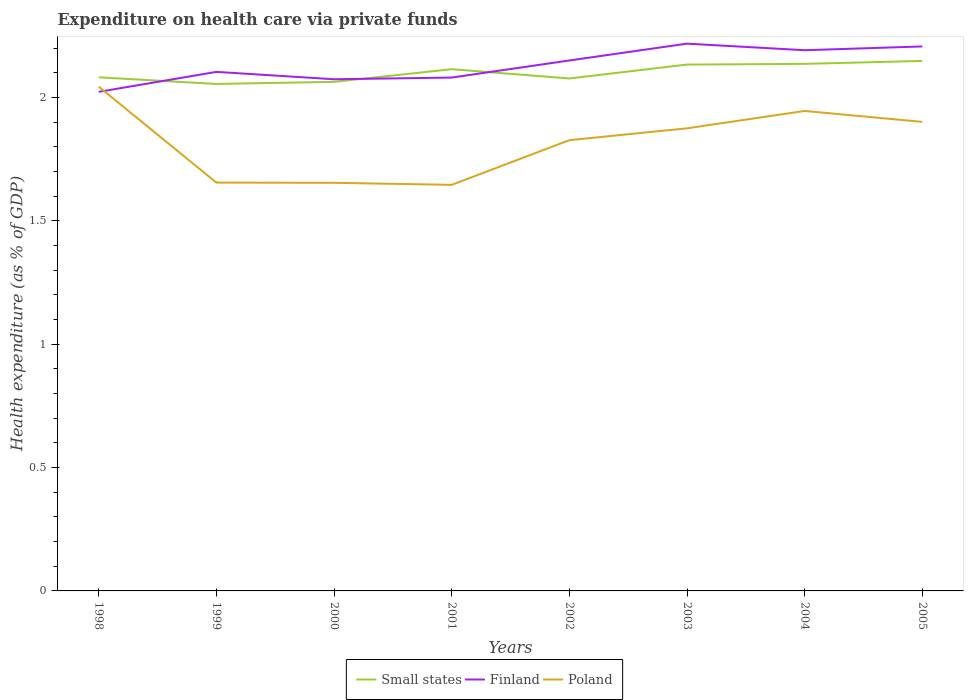Does the line corresponding to Poland intersect with the line corresponding to Small states?
Ensure brevity in your answer.  No. Across all years, what is the maximum expenditure made on health care in Poland?
Your response must be concise. 1.65. In which year was the expenditure made on health care in Poland maximum?
Your answer should be very brief. 2001. What is the total expenditure made on health care in Finland in the graph?
Ensure brevity in your answer.  -0.14. What is the difference between the highest and the second highest expenditure made on health care in Small states?
Provide a short and direct response. 0.09. What is the difference between the highest and the lowest expenditure made on health care in Poland?
Provide a succinct answer. 5. Is the expenditure made on health care in Poland strictly greater than the expenditure made on health care in Small states over the years?
Make the answer very short. Yes. How many years are there in the graph?
Your answer should be compact. 8. Does the graph contain any zero values?
Make the answer very short. No. Where does the legend appear in the graph?
Provide a short and direct response. Bottom center. How are the legend labels stacked?
Ensure brevity in your answer.  Horizontal. What is the title of the graph?
Keep it short and to the point. Expenditure on health care via private funds. What is the label or title of the Y-axis?
Your answer should be very brief. Health expenditure (as % of GDP). What is the Health expenditure (as % of GDP) of Small states in 1998?
Your answer should be compact. 2.08. What is the Health expenditure (as % of GDP) in Finland in 1998?
Provide a short and direct response. 2.02. What is the Health expenditure (as % of GDP) of Poland in 1998?
Your answer should be very brief. 2.04. What is the Health expenditure (as % of GDP) of Small states in 1999?
Your answer should be compact. 2.06. What is the Health expenditure (as % of GDP) in Finland in 1999?
Your response must be concise. 2.1. What is the Health expenditure (as % of GDP) of Poland in 1999?
Offer a terse response. 1.66. What is the Health expenditure (as % of GDP) of Small states in 2000?
Keep it short and to the point. 2.06. What is the Health expenditure (as % of GDP) in Finland in 2000?
Give a very brief answer. 2.07. What is the Health expenditure (as % of GDP) in Poland in 2000?
Make the answer very short. 1.65. What is the Health expenditure (as % of GDP) in Small states in 2001?
Offer a very short reply. 2.12. What is the Health expenditure (as % of GDP) of Finland in 2001?
Make the answer very short. 2.08. What is the Health expenditure (as % of GDP) of Poland in 2001?
Ensure brevity in your answer.  1.65. What is the Health expenditure (as % of GDP) of Small states in 2002?
Your answer should be compact. 2.08. What is the Health expenditure (as % of GDP) in Finland in 2002?
Your answer should be very brief. 2.15. What is the Health expenditure (as % of GDP) in Poland in 2002?
Give a very brief answer. 1.83. What is the Health expenditure (as % of GDP) in Small states in 2003?
Offer a very short reply. 2.13. What is the Health expenditure (as % of GDP) of Finland in 2003?
Provide a short and direct response. 2.22. What is the Health expenditure (as % of GDP) of Poland in 2003?
Provide a succinct answer. 1.88. What is the Health expenditure (as % of GDP) in Small states in 2004?
Provide a short and direct response. 2.14. What is the Health expenditure (as % of GDP) of Finland in 2004?
Ensure brevity in your answer.  2.19. What is the Health expenditure (as % of GDP) of Poland in 2004?
Offer a very short reply. 1.95. What is the Health expenditure (as % of GDP) of Small states in 2005?
Offer a very short reply. 2.15. What is the Health expenditure (as % of GDP) of Finland in 2005?
Make the answer very short. 2.21. What is the Health expenditure (as % of GDP) in Poland in 2005?
Your answer should be very brief. 1.9. Across all years, what is the maximum Health expenditure (as % of GDP) of Small states?
Provide a short and direct response. 2.15. Across all years, what is the maximum Health expenditure (as % of GDP) of Finland?
Your response must be concise. 2.22. Across all years, what is the maximum Health expenditure (as % of GDP) of Poland?
Provide a succinct answer. 2.04. Across all years, what is the minimum Health expenditure (as % of GDP) of Small states?
Provide a succinct answer. 2.06. Across all years, what is the minimum Health expenditure (as % of GDP) in Finland?
Your answer should be compact. 2.02. Across all years, what is the minimum Health expenditure (as % of GDP) of Poland?
Offer a terse response. 1.65. What is the total Health expenditure (as % of GDP) of Small states in the graph?
Offer a terse response. 16.82. What is the total Health expenditure (as % of GDP) of Finland in the graph?
Your answer should be very brief. 17.05. What is the total Health expenditure (as % of GDP) in Poland in the graph?
Your response must be concise. 14.55. What is the difference between the Health expenditure (as % of GDP) in Small states in 1998 and that in 1999?
Give a very brief answer. 0.03. What is the difference between the Health expenditure (as % of GDP) of Finland in 1998 and that in 1999?
Give a very brief answer. -0.08. What is the difference between the Health expenditure (as % of GDP) of Poland in 1998 and that in 1999?
Ensure brevity in your answer.  0.39. What is the difference between the Health expenditure (as % of GDP) of Small states in 1998 and that in 2000?
Give a very brief answer. 0.02. What is the difference between the Health expenditure (as % of GDP) in Finland in 1998 and that in 2000?
Provide a succinct answer. -0.05. What is the difference between the Health expenditure (as % of GDP) in Poland in 1998 and that in 2000?
Your answer should be very brief. 0.39. What is the difference between the Health expenditure (as % of GDP) of Small states in 1998 and that in 2001?
Provide a succinct answer. -0.03. What is the difference between the Health expenditure (as % of GDP) in Finland in 1998 and that in 2001?
Ensure brevity in your answer.  -0.06. What is the difference between the Health expenditure (as % of GDP) in Poland in 1998 and that in 2001?
Offer a terse response. 0.4. What is the difference between the Health expenditure (as % of GDP) of Small states in 1998 and that in 2002?
Offer a very short reply. 0. What is the difference between the Health expenditure (as % of GDP) of Finland in 1998 and that in 2002?
Keep it short and to the point. -0.13. What is the difference between the Health expenditure (as % of GDP) of Poland in 1998 and that in 2002?
Provide a short and direct response. 0.22. What is the difference between the Health expenditure (as % of GDP) in Small states in 1998 and that in 2003?
Give a very brief answer. -0.05. What is the difference between the Health expenditure (as % of GDP) in Finland in 1998 and that in 2003?
Offer a terse response. -0.2. What is the difference between the Health expenditure (as % of GDP) of Poland in 1998 and that in 2003?
Offer a very short reply. 0.17. What is the difference between the Health expenditure (as % of GDP) of Small states in 1998 and that in 2004?
Keep it short and to the point. -0.05. What is the difference between the Health expenditure (as % of GDP) in Finland in 1998 and that in 2004?
Your answer should be compact. -0.17. What is the difference between the Health expenditure (as % of GDP) in Poland in 1998 and that in 2004?
Make the answer very short. 0.1. What is the difference between the Health expenditure (as % of GDP) of Small states in 1998 and that in 2005?
Your response must be concise. -0.07. What is the difference between the Health expenditure (as % of GDP) of Finland in 1998 and that in 2005?
Provide a short and direct response. -0.18. What is the difference between the Health expenditure (as % of GDP) in Poland in 1998 and that in 2005?
Your answer should be compact. 0.14. What is the difference between the Health expenditure (as % of GDP) of Small states in 1999 and that in 2000?
Offer a terse response. -0.01. What is the difference between the Health expenditure (as % of GDP) in Finland in 1999 and that in 2000?
Offer a terse response. 0.03. What is the difference between the Health expenditure (as % of GDP) in Poland in 1999 and that in 2000?
Your response must be concise. 0. What is the difference between the Health expenditure (as % of GDP) in Small states in 1999 and that in 2001?
Provide a succinct answer. -0.06. What is the difference between the Health expenditure (as % of GDP) of Finland in 1999 and that in 2001?
Your answer should be very brief. 0.02. What is the difference between the Health expenditure (as % of GDP) in Poland in 1999 and that in 2001?
Offer a terse response. 0.01. What is the difference between the Health expenditure (as % of GDP) of Small states in 1999 and that in 2002?
Your answer should be very brief. -0.02. What is the difference between the Health expenditure (as % of GDP) of Finland in 1999 and that in 2002?
Offer a very short reply. -0.05. What is the difference between the Health expenditure (as % of GDP) in Poland in 1999 and that in 2002?
Your answer should be compact. -0.17. What is the difference between the Health expenditure (as % of GDP) of Small states in 1999 and that in 2003?
Make the answer very short. -0.08. What is the difference between the Health expenditure (as % of GDP) in Finland in 1999 and that in 2003?
Make the answer very short. -0.11. What is the difference between the Health expenditure (as % of GDP) of Poland in 1999 and that in 2003?
Offer a terse response. -0.22. What is the difference between the Health expenditure (as % of GDP) in Small states in 1999 and that in 2004?
Make the answer very short. -0.08. What is the difference between the Health expenditure (as % of GDP) in Finland in 1999 and that in 2004?
Ensure brevity in your answer.  -0.09. What is the difference between the Health expenditure (as % of GDP) of Poland in 1999 and that in 2004?
Offer a terse response. -0.29. What is the difference between the Health expenditure (as % of GDP) of Small states in 1999 and that in 2005?
Keep it short and to the point. -0.09. What is the difference between the Health expenditure (as % of GDP) of Finland in 1999 and that in 2005?
Your answer should be compact. -0.1. What is the difference between the Health expenditure (as % of GDP) in Poland in 1999 and that in 2005?
Ensure brevity in your answer.  -0.25. What is the difference between the Health expenditure (as % of GDP) in Small states in 2000 and that in 2001?
Offer a very short reply. -0.05. What is the difference between the Health expenditure (as % of GDP) of Finland in 2000 and that in 2001?
Keep it short and to the point. -0.01. What is the difference between the Health expenditure (as % of GDP) in Poland in 2000 and that in 2001?
Give a very brief answer. 0.01. What is the difference between the Health expenditure (as % of GDP) of Small states in 2000 and that in 2002?
Offer a very short reply. -0.01. What is the difference between the Health expenditure (as % of GDP) of Finland in 2000 and that in 2002?
Offer a terse response. -0.08. What is the difference between the Health expenditure (as % of GDP) in Poland in 2000 and that in 2002?
Provide a succinct answer. -0.17. What is the difference between the Health expenditure (as % of GDP) of Small states in 2000 and that in 2003?
Offer a very short reply. -0.07. What is the difference between the Health expenditure (as % of GDP) in Finland in 2000 and that in 2003?
Ensure brevity in your answer.  -0.14. What is the difference between the Health expenditure (as % of GDP) in Poland in 2000 and that in 2003?
Ensure brevity in your answer.  -0.22. What is the difference between the Health expenditure (as % of GDP) of Small states in 2000 and that in 2004?
Make the answer very short. -0.07. What is the difference between the Health expenditure (as % of GDP) in Finland in 2000 and that in 2004?
Ensure brevity in your answer.  -0.12. What is the difference between the Health expenditure (as % of GDP) in Poland in 2000 and that in 2004?
Ensure brevity in your answer.  -0.29. What is the difference between the Health expenditure (as % of GDP) in Small states in 2000 and that in 2005?
Offer a terse response. -0.08. What is the difference between the Health expenditure (as % of GDP) in Finland in 2000 and that in 2005?
Make the answer very short. -0.13. What is the difference between the Health expenditure (as % of GDP) in Poland in 2000 and that in 2005?
Provide a short and direct response. -0.25. What is the difference between the Health expenditure (as % of GDP) in Small states in 2001 and that in 2002?
Offer a very short reply. 0.04. What is the difference between the Health expenditure (as % of GDP) in Finland in 2001 and that in 2002?
Your response must be concise. -0.07. What is the difference between the Health expenditure (as % of GDP) of Poland in 2001 and that in 2002?
Offer a terse response. -0.18. What is the difference between the Health expenditure (as % of GDP) in Small states in 2001 and that in 2003?
Offer a terse response. -0.02. What is the difference between the Health expenditure (as % of GDP) in Finland in 2001 and that in 2003?
Offer a terse response. -0.14. What is the difference between the Health expenditure (as % of GDP) in Poland in 2001 and that in 2003?
Provide a succinct answer. -0.23. What is the difference between the Health expenditure (as % of GDP) in Small states in 2001 and that in 2004?
Make the answer very short. -0.02. What is the difference between the Health expenditure (as % of GDP) of Finland in 2001 and that in 2004?
Provide a short and direct response. -0.11. What is the difference between the Health expenditure (as % of GDP) in Poland in 2001 and that in 2004?
Provide a short and direct response. -0.3. What is the difference between the Health expenditure (as % of GDP) in Small states in 2001 and that in 2005?
Offer a terse response. -0.03. What is the difference between the Health expenditure (as % of GDP) in Finland in 2001 and that in 2005?
Your response must be concise. -0.13. What is the difference between the Health expenditure (as % of GDP) in Poland in 2001 and that in 2005?
Your answer should be very brief. -0.26. What is the difference between the Health expenditure (as % of GDP) in Small states in 2002 and that in 2003?
Offer a terse response. -0.06. What is the difference between the Health expenditure (as % of GDP) in Finland in 2002 and that in 2003?
Keep it short and to the point. -0.07. What is the difference between the Health expenditure (as % of GDP) of Poland in 2002 and that in 2003?
Provide a succinct answer. -0.05. What is the difference between the Health expenditure (as % of GDP) of Small states in 2002 and that in 2004?
Provide a short and direct response. -0.06. What is the difference between the Health expenditure (as % of GDP) in Finland in 2002 and that in 2004?
Your response must be concise. -0.04. What is the difference between the Health expenditure (as % of GDP) in Poland in 2002 and that in 2004?
Your answer should be very brief. -0.12. What is the difference between the Health expenditure (as % of GDP) in Small states in 2002 and that in 2005?
Keep it short and to the point. -0.07. What is the difference between the Health expenditure (as % of GDP) in Finland in 2002 and that in 2005?
Offer a very short reply. -0.06. What is the difference between the Health expenditure (as % of GDP) in Poland in 2002 and that in 2005?
Make the answer very short. -0.07. What is the difference between the Health expenditure (as % of GDP) in Small states in 2003 and that in 2004?
Make the answer very short. -0. What is the difference between the Health expenditure (as % of GDP) in Finland in 2003 and that in 2004?
Ensure brevity in your answer.  0.03. What is the difference between the Health expenditure (as % of GDP) in Poland in 2003 and that in 2004?
Make the answer very short. -0.07. What is the difference between the Health expenditure (as % of GDP) of Small states in 2003 and that in 2005?
Give a very brief answer. -0.01. What is the difference between the Health expenditure (as % of GDP) in Finland in 2003 and that in 2005?
Ensure brevity in your answer.  0.01. What is the difference between the Health expenditure (as % of GDP) in Poland in 2003 and that in 2005?
Your response must be concise. -0.03. What is the difference between the Health expenditure (as % of GDP) of Small states in 2004 and that in 2005?
Offer a terse response. -0.01. What is the difference between the Health expenditure (as % of GDP) in Finland in 2004 and that in 2005?
Your response must be concise. -0.02. What is the difference between the Health expenditure (as % of GDP) in Poland in 2004 and that in 2005?
Ensure brevity in your answer.  0.04. What is the difference between the Health expenditure (as % of GDP) in Small states in 1998 and the Health expenditure (as % of GDP) in Finland in 1999?
Ensure brevity in your answer.  -0.02. What is the difference between the Health expenditure (as % of GDP) of Small states in 1998 and the Health expenditure (as % of GDP) of Poland in 1999?
Provide a succinct answer. 0.43. What is the difference between the Health expenditure (as % of GDP) in Finland in 1998 and the Health expenditure (as % of GDP) in Poland in 1999?
Offer a very short reply. 0.37. What is the difference between the Health expenditure (as % of GDP) of Small states in 1998 and the Health expenditure (as % of GDP) of Finland in 2000?
Your response must be concise. 0.01. What is the difference between the Health expenditure (as % of GDP) in Small states in 1998 and the Health expenditure (as % of GDP) in Poland in 2000?
Offer a very short reply. 0.43. What is the difference between the Health expenditure (as % of GDP) of Finland in 1998 and the Health expenditure (as % of GDP) of Poland in 2000?
Offer a terse response. 0.37. What is the difference between the Health expenditure (as % of GDP) of Small states in 1998 and the Health expenditure (as % of GDP) of Finland in 2001?
Ensure brevity in your answer.  0. What is the difference between the Health expenditure (as % of GDP) of Small states in 1998 and the Health expenditure (as % of GDP) of Poland in 2001?
Your answer should be compact. 0.44. What is the difference between the Health expenditure (as % of GDP) of Finland in 1998 and the Health expenditure (as % of GDP) of Poland in 2001?
Offer a very short reply. 0.38. What is the difference between the Health expenditure (as % of GDP) of Small states in 1998 and the Health expenditure (as % of GDP) of Finland in 2002?
Give a very brief answer. -0.07. What is the difference between the Health expenditure (as % of GDP) of Small states in 1998 and the Health expenditure (as % of GDP) of Poland in 2002?
Your response must be concise. 0.26. What is the difference between the Health expenditure (as % of GDP) in Finland in 1998 and the Health expenditure (as % of GDP) in Poland in 2002?
Your answer should be very brief. 0.2. What is the difference between the Health expenditure (as % of GDP) in Small states in 1998 and the Health expenditure (as % of GDP) in Finland in 2003?
Provide a short and direct response. -0.14. What is the difference between the Health expenditure (as % of GDP) of Small states in 1998 and the Health expenditure (as % of GDP) of Poland in 2003?
Offer a terse response. 0.21. What is the difference between the Health expenditure (as % of GDP) in Finland in 1998 and the Health expenditure (as % of GDP) in Poland in 2003?
Provide a short and direct response. 0.15. What is the difference between the Health expenditure (as % of GDP) in Small states in 1998 and the Health expenditure (as % of GDP) in Finland in 2004?
Offer a terse response. -0.11. What is the difference between the Health expenditure (as % of GDP) in Small states in 1998 and the Health expenditure (as % of GDP) in Poland in 2004?
Give a very brief answer. 0.14. What is the difference between the Health expenditure (as % of GDP) in Finland in 1998 and the Health expenditure (as % of GDP) in Poland in 2004?
Provide a succinct answer. 0.08. What is the difference between the Health expenditure (as % of GDP) in Small states in 1998 and the Health expenditure (as % of GDP) in Finland in 2005?
Keep it short and to the point. -0.13. What is the difference between the Health expenditure (as % of GDP) of Small states in 1998 and the Health expenditure (as % of GDP) of Poland in 2005?
Your answer should be very brief. 0.18. What is the difference between the Health expenditure (as % of GDP) of Finland in 1998 and the Health expenditure (as % of GDP) of Poland in 2005?
Provide a succinct answer. 0.12. What is the difference between the Health expenditure (as % of GDP) of Small states in 1999 and the Health expenditure (as % of GDP) of Finland in 2000?
Provide a succinct answer. -0.02. What is the difference between the Health expenditure (as % of GDP) of Small states in 1999 and the Health expenditure (as % of GDP) of Poland in 2000?
Offer a very short reply. 0.4. What is the difference between the Health expenditure (as % of GDP) in Finland in 1999 and the Health expenditure (as % of GDP) in Poland in 2000?
Your response must be concise. 0.45. What is the difference between the Health expenditure (as % of GDP) of Small states in 1999 and the Health expenditure (as % of GDP) of Finland in 2001?
Your answer should be compact. -0.03. What is the difference between the Health expenditure (as % of GDP) in Small states in 1999 and the Health expenditure (as % of GDP) in Poland in 2001?
Your answer should be compact. 0.41. What is the difference between the Health expenditure (as % of GDP) in Finland in 1999 and the Health expenditure (as % of GDP) in Poland in 2001?
Keep it short and to the point. 0.46. What is the difference between the Health expenditure (as % of GDP) in Small states in 1999 and the Health expenditure (as % of GDP) in Finland in 2002?
Provide a short and direct response. -0.1. What is the difference between the Health expenditure (as % of GDP) of Small states in 1999 and the Health expenditure (as % of GDP) of Poland in 2002?
Your response must be concise. 0.23. What is the difference between the Health expenditure (as % of GDP) in Finland in 1999 and the Health expenditure (as % of GDP) in Poland in 2002?
Offer a very short reply. 0.28. What is the difference between the Health expenditure (as % of GDP) of Small states in 1999 and the Health expenditure (as % of GDP) of Finland in 2003?
Keep it short and to the point. -0.16. What is the difference between the Health expenditure (as % of GDP) of Small states in 1999 and the Health expenditure (as % of GDP) of Poland in 2003?
Your response must be concise. 0.18. What is the difference between the Health expenditure (as % of GDP) of Finland in 1999 and the Health expenditure (as % of GDP) of Poland in 2003?
Keep it short and to the point. 0.23. What is the difference between the Health expenditure (as % of GDP) of Small states in 1999 and the Health expenditure (as % of GDP) of Finland in 2004?
Ensure brevity in your answer.  -0.14. What is the difference between the Health expenditure (as % of GDP) of Small states in 1999 and the Health expenditure (as % of GDP) of Poland in 2004?
Offer a terse response. 0.11. What is the difference between the Health expenditure (as % of GDP) in Finland in 1999 and the Health expenditure (as % of GDP) in Poland in 2004?
Your answer should be compact. 0.16. What is the difference between the Health expenditure (as % of GDP) in Small states in 1999 and the Health expenditure (as % of GDP) in Finland in 2005?
Keep it short and to the point. -0.15. What is the difference between the Health expenditure (as % of GDP) of Small states in 1999 and the Health expenditure (as % of GDP) of Poland in 2005?
Your answer should be very brief. 0.15. What is the difference between the Health expenditure (as % of GDP) in Finland in 1999 and the Health expenditure (as % of GDP) in Poland in 2005?
Your answer should be compact. 0.2. What is the difference between the Health expenditure (as % of GDP) of Small states in 2000 and the Health expenditure (as % of GDP) of Finland in 2001?
Provide a succinct answer. -0.02. What is the difference between the Health expenditure (as % of GDP) in Small states in 2000 and the Health expenditure (as % of GDP) in Poland in 2001?
Offer a terse response. 0.42. What is the difference between the Health expenditure (as % of GDP) of Finland in 2000 and the Health expenditure (as % of GDP) of Poland in 2001?
Your response must be concise. 0.43. What is the difference between the Health expenditure (as % of GDP) of Small states in 2000 and the Health expenditure (as % of GDP) of Finland in 2002?
Make the answer very short. -0.09. What is the difference between the Health expenditure (as % of GDP) in Small states in 2000 and the Health expenditure (as % of GDP) in Poland in 2002?
Keep it short and to the point. 0.24. What is the difference between the Health expenditure (as % of GDP) of Finland in 2000 and the Health expenditure (as % of GDP) of Poland in 2002?
Provide a succinct answer. 0.25. What is the difference between the Health expenditure (as % of GDP) in Small states in 2000 and the Health expenditure (as % of GDP) in Finland in 2003?
Offer a terse response. -0.15. What is the difference between the Health expenditure (as % of GDP) in Small states in 2000 and the Health expenditure (as % of GDP) in Poland in 2003?
Your answer should be compact. 0.19. What is the difference between the Health expenditure (as % of GDP) in Finland in 2000 and the Health expenditure (as % of GDP) in Poland in 2003?
Ensure brevity in your answer.  0.2. What is the difference between the Health expenditure (as % of GDP) of Small states in 2000 and the Health expenditure (as % of GDP) of Finland in 2004?
Provide a succinct answer. -0.13. What is the difference between the Health expenditure (as % of GDP) in Small states in 2000 and the Health expenditure (as % of GDP) in Poland in 2004?
Offer a very short reply. 0.12. What is the difference between the Health expenditure (as % of GDP) of Finland in 2000 and the Health expenditure (as % of GDP) of Poland in 2004?
Your response must be concise. 0.13. What is the difference between the Health expenditure (as % of GDP) of Small states in 2000 and the Health expenditure (as % of GDP) of Finland in 2005?
Provide a succinct answer. -0.14. What is the difference between the Health expenditure (as % of GDP) of Small states in 2000 and the Health expenditure (as % of GDP) of Poland in 2005?
Provide a short and direct response. 0.16. What is the difference between the Health expenditure (as % of GDP) in Finland in 2000 and the Health expenditure (as % of GDP) in Poland in 2005?
Your answer should be very brief. 0.17. What is the difference between the Health expenditure (as % of GDP) of Small states in 2001 and the Health expenditure (as % of GDP) of Finland in 2002?
Give a very brief answer. -0.04. What is the difference between the Health expenditure (as % of GDP) in Small states in 2001 and the Health expenditure (as % of GDP) in Poland in 2002?
Offer a terse response. 0.29. What is the difference between the Health expenditure (as % of GDP) in Finland in 2001 and the Health expenditure (as % of GDP) in Poland in 2002?
Provide a short and direct response. 0.25. What is the difference between the Health expenditure (as % of GDP) in Small states in 2001 and the Health expenditure (as % of GDP) in Finland in 2003?
Offer a terse response. -0.1. What is the difference between the Health expenditure (as % of GDP) in Small states in 2001 and the Health expenditure (as % of GDP) in Poland in 2003?
Offer a terse response. 0.24. What is the difference between the Health expenditure (as % of GDP) in Finland in 2001 and the Health expenditure (as % of GDP) in Poland in 2003?
Ensure brevity in your answer.  0.21. What is the difference between the Health expenditure (as % of GDP) of Small states in 2001 and the Health expenditure (as % of GDP) of Finland in 2004?
Ensure brevity in your answer.  -0.08. What is the difference between the Health expenditure (as % of GDP) in Small states in 2001 and the Health expenditure (as % of GDP) in Poland in 2004?
Give a very brief answer. 0.17. What is the difference between the Health expenditure (as % of GDP) of Finland in 2001 and the Health expenditure (as % of GDP) of Poland in 2004?
Make the answer very short. 0.14. What is the difference between the Health expenditure (as % of GDP) of Small states in 2001 and the Health expenditure (as % of GDP) of Finland in 2005?
Provide a succinct answer. -0.09. What is the difference between the Health expenditure (as % of GDP) of Small states in 2001 and the Health expenditure (as % of GDP) of Poland in 2005?
Keep it short and to the point. 0.21. What is the difference between the Health expenditure (as % of GDP) in Finland in 2001 and the Health expenditure (as % of GDP) in Poland in 2005?
Offer a very short reply. 0.18. What is the difference between the Health expenditure (as % of GDP) of Small states in 2002 and the Health expenditure (as % of GDP) of Finland in 2003?
Make the answer very short. -0.14. What is the difference between the Health expenditure (as % of GDP) of Small states in 2002 and the Health expenditure (as % of GDP) of Poland in 2003?
Your response must be concise. 0.2. What is the difference between the Health expenditure (as % of GDP) in Finland in 2002 and the Health expenditure (as % of GDP) in Poland in 2003?
Offer a very short reply. 0.28. What is the difference between the Health expenditure (as % of GDP) in Small states in 2002 and the Health expenditure (as % of GDP) in Finland in 2004?
Provide a short and direct response. -0.11. What is the difference between the Health expenditure (as % of GDP) of Small states in 2002 and the Health expenditure (as % of GDP) of Poland in 2004?
Your answer should be compact. 0.13. What is the difference between the Health expenditure (as % of GDP) of Finland in 2002 and the Health expenditure (as % of GDP) of Poland in 2004?
Provide a short and direct response. 0.2. What is the difference between the Health expenditure (as % of GDP) of Small states in 2002 and the Health expenditure (as % of GDP) of Finland in 2005?
Provide a short and direct response. -0.13. What is the difference between the Health expenditure (as % of GDP) in Small states in 2002 and the Health expenditure (as % of GDP) in Poland in 2005?
Your response must be concise. 0.18. What is the difference between the Health expenditure (as % of GDP) in Finland in 2002 and the Health expenditure (as % of GDP) in Poland in 2005?
Keep it short and to the point. 0.25. What is the difference between the Health expenditure (as % of GDP) of Small states in 2003 and the Health expenditure (as % of GDP) of Finland in 2004?
Provide a short and direct response. -0.06. What is the difference between the Health expenditure (as % of GDP) in Small states in 2003 and the Health expenditure (as % of GDP) in Poland in 2004?
Keep it short and to the point. 0.19. What is the difference between the Health expenditure (as % of GDP) in Finland in 2003 and the Health expenditure (as % of GDP) in Poland in 2004?
Your answer should be very brief. 0.27. What is the difference between the Health expenditure (as % of GDP) in Small states in 2003 and the Health expenditure (as % of GDP) in Finland in 2005?
Provide a short and direct response. -0.07. What is the difference between the Health expenditure (as % of GDP) of Small states in 2003 and the Health expenditure (as % of GDP) of Poland in 2005?
Your response must be concise. 0.23. What is the difference between the Health expenditure (as % of GDP) in Finland in 2003 and the Health expenditure (as % of GDP) in Poland in 2005?
Keep it short and to the point. 0.32. What is the difference between the Health expenditure (as % of GDP) in Small states in 2004 and the Health expenditure (as % of GDP) in Finland in 2005?
Provide a short and direct response. -0.07. What is the difference between the Health expenditure (as % of GDP) in Small states in 2004 and the Health expenditure (as % of GDP) in Poland in 2005?
Your response must be concise. 0.24. What is the difference between the Health expenditure (as % of GDP) of Finland in 2004 and the Health expenditure (as % of GDP) of Poland in 2005?
Your answer should be very brief. 0.29. What is the average Health expenditure (as % of GDP) of Small states per year?
Make the answer very short. 2.1. What is the average Health expenditure (as % of GDP) of Finland per year?
Offer a very short reply. 2.13. What is the average Health expenditure (as % of GDP) of Poland per year?
Your response must be concise. 1.82. In the year 1998, what is the difference between the Health expenditure (as % of GDP) in Small states and Health expenditure (as % of GDP) in Finland?
Offer a very short reply. 0.06. In the year 1998, what is the difference between the Health expenditure (as % of GDP) in Small states and Health expenditure (as % of GDP) in Poland?
Offer a terse response. 0.04. In the year 1998, what is the difference between the Health expenditure (as % of GDP) of Finland and Health expenditure (as % of GDP) of Poland?
Your answer should be compact. -0.02. In the year 1999, what is the difference between the Health expenditure (as % of GDP) of Small states and Health expenditure (as % of GDP) of Finland?
Offer a very short reply. -0.05. In the year 1999, what is the difference between the Health expenditure (as % of GDP) in Small states and Health expenditure (as % of GDP) in Poland?
Make the answer very short. 0.4. In the year 1999, what is the difference between the Health expenditure (as % of GDP) in Finland and Health expenditure (as % of GDP) in Poland?
Make the answer very short. 0.45. In the year 2000, what is the difference between the Health expenditure (as % of GDP) in Small states and Health expenditure (as % of GDP) in Finland?
Ensure brevity in your answer.  -0.01. In the year 2000, what is the difference between the Health expenditure (as % of GDP) in Small states and Health expenditure (as % of GDP) in Poland?
Provide a short and direct response. 0.41. In the year 2000, what is the difference between the Health expenditure (as % of GDP) in Finland and Health expenditure (as % of GDP) in Poland?
Offer a terse response. 0.42. In the year 2001, what is the difference between the Health expenditure (as % of GDP) of Small states and Health expenditure (as % of GDP) of Finland?
Your answer should be very brief. 0.03. In the year 2001, what is the difference between the Health expenditure (as % of GDP) of Small states and Health expenditure (as % of GDP) of Poland?
Provide a short and direct response. 0.47. In the year 2001, what is the difference between the Health expenditure (as % of GDP) in Finland and Health expenditure (as % of GDP) in Poland?
Your response must be concise. 0.43. In the year 2002, what is the difference between the Health expenditure (as % of GDP) of Small states and Health expenditure (as % of GDP) of Finland?
Offer a very short reply. -0.07. In the year 2002, what is the difference between the Health expenditure (as % of GDP) in Small states and Health expenditure (as % of GDP) in Poland?
Your answer should be very brief. 0.25. In the year 2002, what is the difference between the Health expenditure (as % of GDP) in Finland and Health expenditure (as % of GDP) in Poland?
Your answer should be compact. 0.32. In the year 2003, what is the difference between the Health expenditure (as % of GDP) in Small states and Health expenditure (as % of GDP) in Finland?
Your response must be concise. -0.08. In the year 2003, what is the difference between the Health expenditure (as % of GDP) in Small states and Health expenditure (as % of GDP) in Poland?
Your response must be concise. 0.26. In the year 2003, what is the difference between the Health expenditure (as % of GDP) in Finland and Health expenditure (as % of GDP) in Poland?
Your answer should be very brief. 0.34. In the year 2004, what is the difference between the Health expenditure (as % of GDP) of Small states and Health expenditure (as % of GDP) of Finland?
Offer a very short reply. -0.06. In the year 2004, what is the difference between the Health expenditure (as % of GDP) in Small states and Health expenditure (as % of GDP) in Poland?
Ensure brevity in your answer.  0.19. In the year 2004, what is the difference between the Health expenditure (as % of GDP) of Finland and Health expenditure (as % of GDP) of Poland?
Provide a short and direct response. 0.25. In the year 2005, what is the difference between the Health expenditure (as % of GDP) in Small states and Health expenditure (as % of GDP) in Finland?
Make the answer very short. -0.06. In the year 2005, what is the difference between the Health expenditure (as % of GDP) in Small states and Health expenditure (as % of GDP) in Poland?
Provide a succinct answer. 0.25. In the year 2005, what is the difference between the Health expenditure (as % of GDP) in Finland and Health expenditure (as % of GDP) in Poland?
Offer a terse response. 0.31. What is the ratio of the Health expenditure (as % of GDP) in Small states in 1998 to that in 1999?
Your answer should be compact. 1.01. What is the ratio of the Health expenditure (as % of GDP) of Finland in 1998 to that in 1999?
Your answer should be compact. 0.96. What is the ratio of the Health expenditure (as % of GDP) of Poland in 1998 to that in 1999?
Provide a succinct answer. 1.23. What is the ratio of the Health expenditure (as % of GDP) of Small states in 1998 to that in 2000?
Your answer should be very brief. 1.01. What is the ratio of the Health expenditure (as % of GDP) in Finland in 1998 to that in 2000?
Make the answer very short. 0.98. What is the ratio of the Health expenditure (as % of GDP) of Poland in 1998 to that in 2000?
Offer a terse response. 1.24. What is the ratio of the Health expenditure (as % of GDP) in Small states in 1998 to that in 2001?
Provide a short and direct response. 0.98. What is the ratio of the Health expenditure (as % of GDP) of Finland in 1998 to that in 2001?
Provide a short and direct response. 0.97. What is the ratio of the Health expenditure (as % of GDP) of Poland in 1998 to that in 2001?
Keep it short and to the point. 1.24. What is the ratio of the Health expenditure (as % of GDP) of Small states in 1998 to that in 2002?
Offer a very short reply. 1. What is the ratio of the Health expenditure (as % of GDP) of Finland in 1998 to that in 2002?
Keep it short and to the point. 0.94. What is the ratio of the Health expenditure (as % of GDP) of Poland in 1998 to that in 2002?
Your response must be concise. 1.12. What is the ratio of the Health expenditure (as % of GDP) in Small states in 1998 to that in 2003?
Your answer should be compact. 0.98. What is the ratio of the Health expenditure (as % of GDP) of Finland in 1998 to that in 2003?
Your answer should be very brief. 0.91. What is the ratio of the Health expenditure (as % of GDP) of Poland in 1998 to that in 2003?
Make the answer very short. 1.09. What is the ratio of the Health expenditure (as % of GDP) of Small states in 1998 to that in 2004?
Provide a short and direct response. 0.97. What is the ratio of the Health expenditure (as % of GDP) of Finland in 1998 to that in 2004?
Give a very brief answer. 0.92. What is the ratio of the Health expenditure (as % of GDP) in Poland in 1998 to that in 2004?
Ensure brevity in your answer.  1.05. What is the ratio of the Health expenditure (as % of GDP) of Small states in 1998 to that in 2005?
Your answer should be very brief. 0.97. What is the ratio of the Health expenditure (as % of GDP) of Finland in 1998 to that in 2005?
Your answer should be very brief. 0.92. What is the ratio of the Health expenditure (as % of GDP) in Poland in 1998 to that in 2005?
Offer a very short reply. 1.08. What is the ratio of the Health expenditure (as % of GDP) of Finland in 1999 to that in 2000?
Your response must be concise. 1.01. What is the ratio of the Health expenditure (as % of GDP) of Poland in 1999 to that in 2000?
Give a very brief answer. 1. What is the ratio of the Health expenditure (as % of GDP) in Small states in 1999 to that in 2001?
Provide a succinct answer. 0.97. What is the ratio of the Health expenditure (as % of GDP) of Finland in 1999 to that in 2001?
Make the answer very short. 1.01. What is the ratio of the Health expenditure (as % of GDP) in Poland in 1999 to that in 2001?
Provide a succinct answer. 1.01. What is the ratio of the Health expenditure (as % of GDP) in Small states in 1999 to that in 2002?
Offer a terse response. 0.99. What is the ratio of the Health expenditure (as % of GDP) of Finland in 1999 to that in 2002?
Your answer should be compact. 0.98. What is the ratio of the Health expenditure (as % of GDP) of Poland in 1999 to that in 2002?
Your answer should be very brief. 0.91. What is the ratio of the Health expenditure (as % of GDP) of Small states in 1999 to that in 2003?
Provide a short and direct response. 0.96. What is the ratio of the Health expenditure (as % of GDP) of Finland in 1999 to that in 2003?
Keep it short and to the point. 0.95. What is the ratio of the Health expenditure (as % of GDP) of Poland in 1999 to that in 2003?
Provide a short and direct response. 0.88. What is the ratio of the Health expenditure (as % of GDP) of Small states in 1999 to that in 2004?
Provide a succinct answer. 0.96. What is the ratio of the Health expenditure (as % of GDP) of Poland in 1999 to that in 2004?
Your answer should be compact. 0.85. What is the ratio of the Health expenditure (as % of GDP) in Small states in 1999 to that in 2005?
Make the answer very short. 0.96. What is the ratio of the Health expenditure (as % of GDP) in Finland in 1999 to that in 2005?
Offer a terse response. 0.95. What is the ratio of the Health expenditure (as % of GDP) in Poland in 1999 to that in 2005?
Your response must be concise. 0.87. What is the ratio of the Health expenditure (as % of GDP) in Small states in 2000 to that in 2001?
Provide a short and direct response. 0.98. What is the ratio of the Health expenditure (as % of GDP) in Poland in 2000 to that in 2001?
Provide a succinct answer. 1. What is the ratio of the Health expenditure (as % of GDP) in Finland in 2000 to that in 2002?
Ensure brevity in your answer.  0.96. What is the ratio of the Health expenditure (as % of GDP) in Poland in 2000 to that in 2002?
Your answer should be compact. 0.91. What is the ratio of the Health expenditure (as % of GDP) in Small states in 2000 to that in 2003?
Offer a terse response. 0.97. What is the ratio of the Health expenditure (as % of GDP) in Finland in 2000 to that in 2003?
Provide a succinct answer. 0.93. What is the ratio of the Health expenditure (as % of GDP) of Poland in 2000 to that in 2003?
Give a very brief answer. 0.88. What is the ratio of the Health expenditure (as % of GDP) of Small states in 2000 to that in 2004?
Offer a terse response. 0.97. What is the ratio of the Health expenditure (as % of GDP) of Finland in 2000 to that in 2004?
Your answer should be very brief. 0.95. What is the ratio of the Health expenditure (as % of GDP) of Poland in 2000 to that in 2004?
Ensure brevity in your answer.  0.85. What is the ratio of the Health expenditure (as % of GDP) in Small states in 2000 to that in 2005?
Your answer should be compact. 0.96. What is the ratio of the Health expenditure (as % of GDP) in Finland in 2000 to that in 2005?
Your answer should be very brief. 0.94. What is the ratio of the Health expenditure (as % of GDP) in Poland in 2000 to that in 2005?
Keep it short and to the point. 0.87. What is the ratio of the Health expenditure (as % of GDP) in Small states in 2001 to that in 2002?
Your answer should be compact. 1.02. What is the ratio of the Health expenditure (as % of GDP) of Finland in 2001 to that in 2002?
Your response must be concise. 0.97. What is the ratio of the Health expenditure (as % of GDP) of Poland in 2001 to that in 2002?
Provide a succinct answer. 0.9. What is the ratio of the Health expenditure (as % of GDP) of Small states in 2001 to that in 2003?
Offer a terse response. 0.99. What is the ratio of the Health expenditure (as % of GDP) in Finland in 2001 to that in 2003?
Your answer should be very brief. 0.94. What is the ratio of the Health expenditure (as % of GDP) in Poland in 2001 to that in 2003?
Offer a very short reply. 0.88. What is the ratio of the Health expenditure (as % of GDP) in Small states in 2001 to that in 2004?
Offer a very short reply. 0.99. What is the ratio of the Health expenditure (as % of GDP) of Finland in 2001 to that in 2004?
Offer a terse response. 0.95. What is the ratio of the Health expenditure (as % of GDP) of Poland in 2001 to that in 2004?
Give a very brief answer. 0.85. What is the ratio of the Health expenditure (as % of GDP) of Small states in 2001 to that in 2005?
Offer a very short reply. 0.98. What is the ratio of the Health expenditure (as % of GDP) in Finland in 2001 to that in 2005?
Your answer should be very brief. 0.94. What is the ratio of the Health expenditure (as % of GDP) in Poland in 2001 to that in 2005?
Make the answer very short. 0.87. What is the ratio of the Health expenditure (as % of GDP) in Small states in 2002 to that in 2003?
Provide a short and direct response. 0.97. What is the ratio of the Health expenditure (as % of GDP) in Finland in 2002 to that in 2003?
Provide a short and direct response. 0.97. What is the ratio of the Health expenditure (as % of GDP) of Poland in 2002 to that in 2003?
Provide a short and direct response. 0.97. What is the ratio of the Health expenditure (as % of GDP) of Small states in 2002 to that in 2004?
Provide a succinct answer. 0.97. What is the ratio of the Health expenditure (as % of GDP) of Poland in 2002 to that in 2004?
Your answer should be compact. 0.94. What is the ratio of the Health expenditure (as % of GDP) of Small states in 2002 to that in 2005?
Ensure brevity in your answer.  0.97. What is the ratio of the Health expenditure (as % of GDP) of Finland in 2002 to that in 2005?
Your response must be concise. 0.97. What is the ratio of the Health expenditure (as % of GDP) in Finland in 2003 to that in 2004?
Make the answer very short. 1.01. What is the ratio of the Health expenditure (as % of GDP) in Poland in 2003 to that in 2004?
Offer a very short reply. 0.96. What is the ratio of the Health expenditure (as % of GDP) in Small states in 2003 to that in 2005?
Your answer should be very brief. 0.99. What is the ratio of the Health expenditure (as % of GDP) in Poland in 2003 to that in 2005?
Offer a very short reply. 0.99. What is the ratio of the Health expenditure (as % of GDP) in Small states in 2004 to that in 2005?
Provide a short and direct response. 0.99. What is the ratio of the Health expenditure (as % of GDP) in Poland in 2004 to that in 2005?
Offer a terse response. 1.02. What is the difference between the highest and the second highest Health expenditure (as % of GDP) in Small states?
Your answer should be compact. 0.01. What is the difference between the highest and the second highest Health expenditure (as % of GDP) in Finland?
Give a very brief answer. 0.01. What is the difference between the highest and the second highest Health expenditure (as % of GDP) in Poland?
Offer a very short reply. 0.1. What is the difference between the highest and the lowest Health expenditure (as % of GDP) of Small states?
Keep it short and to the point. 0.09. What is the difference between the highest and the lowest Health expenditure (as % of GDP) in Finland?
Offer a very short reply. 0.2. What is the difference between the highest and the lowest Health expenditure (as % of GDP) of Poland?
Your answer should be very brief. 0.4. 